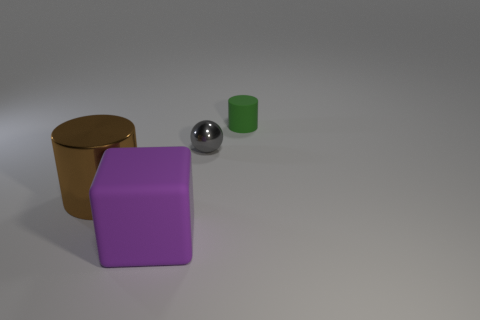Add 1 gray things. How many objects exist? 5 Subtract all balls. How many objects are left? 3 Add 4 brown metallic things. How many brown metallic things are left? 5 Add 3 tiny purple rubber cylinders. How many tiny purple rubber cylinders exist? 3 Subtract 1 green cylinders. How many objects are left? 3 Subtract all large red metal balls. Subtract all large cubes. How many objects are left? 3 